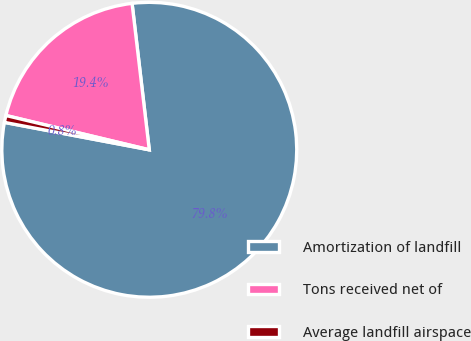Convert chart. <chart><loc_0><loc_0><loc_500><loc_500><pie_chart><fcel>Amortization of landfill<fcel>Tons received net of<fcel>Average landfill airspace<nl><fcel>79.84%<fcel>19.4%<fcel>0.76%<nl></chart> 